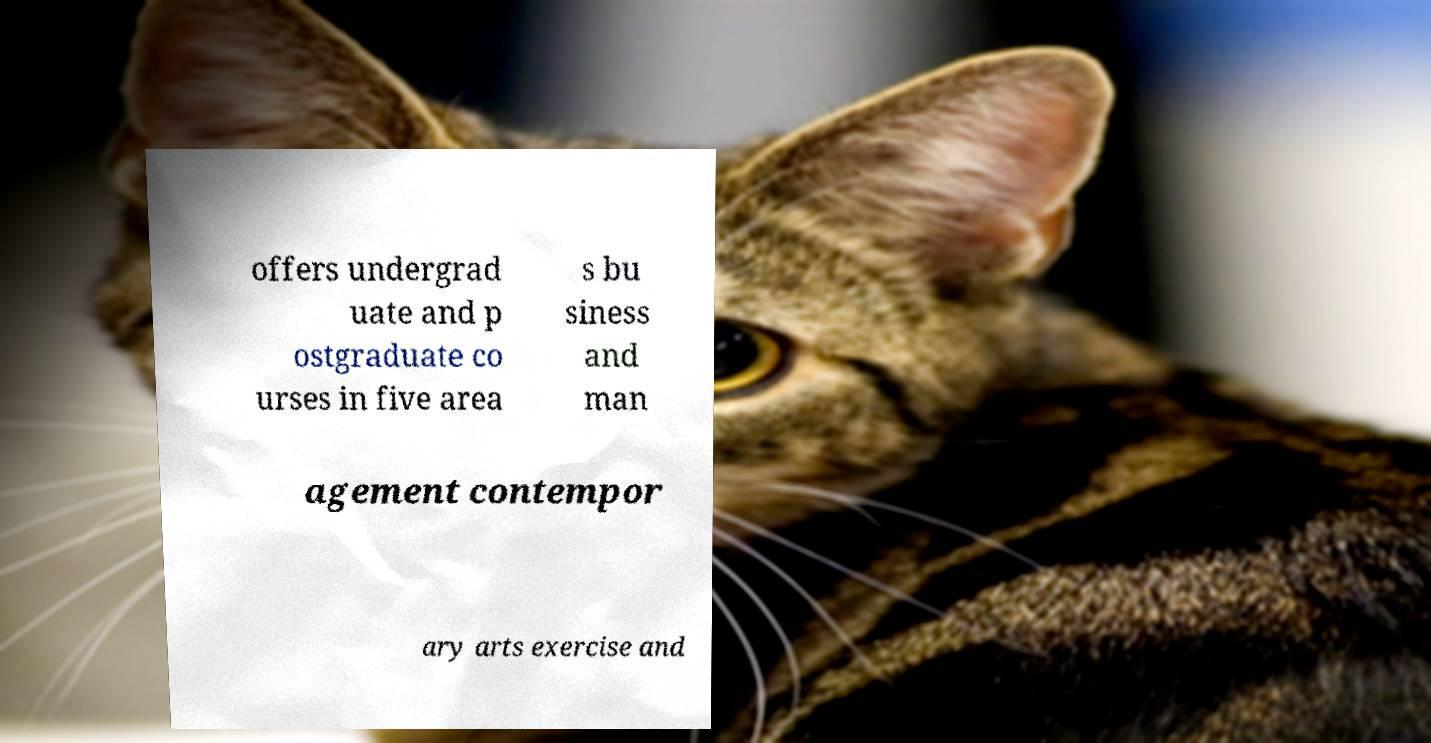What messages or text are displayed in this image? I need them in a readable, typed format. offers undergrad uate and p ostgraduate co urses in five area s bu siness and man agement contempor ary arts exercise and 